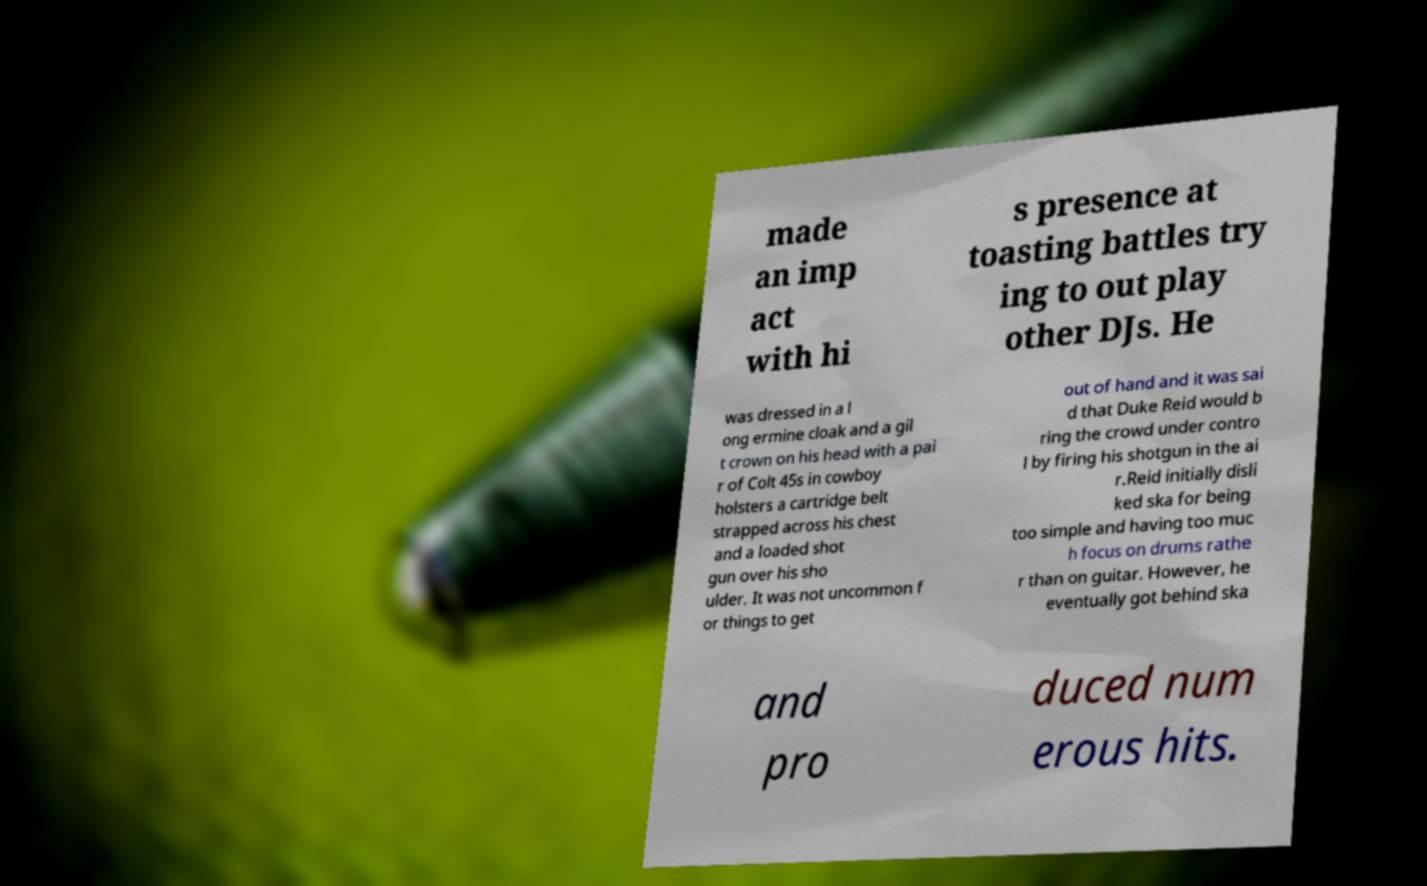Can you read and provide the text displayed in the image?This photo seems to have some interesting text. Can you extract and type it out for me? made an imp act with hi s presence at toasting battles try ing to out play other DJs. He was dressed in a l ong ermine cloak and a gil t crown on his head with a pai r of Colt 45s in cowboy holsters a cartridge belt strapped across his chest and a loaded shot gun over his sho ulder. It was not uncommon f or things to get out of hand and it was sai d that Duke Reid would b ring the crowd under contro l by firing his shotgun in the ai r.Reid initially disli ked ska for being too simple and having too muc h focus on drums rathe r than on guitar. However, he eventually got behind ska and pro duced num erous hits. 